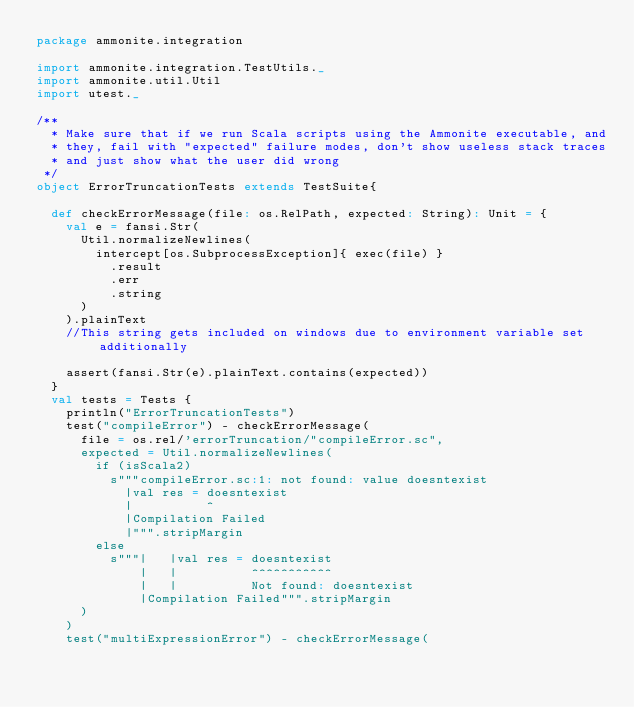Convert code to text. <code><loc_0><loc_0><loc_500><loc_500><_Scala_>package ammonite.integration

import ammonite.integration.TestUtils._
import ammonite.util.Util
import utest._

/**
  * Make sure that if we run Scala scripts using the Ammonite executable, and
  * they, fail with "expected" failure modes, don't show useless stack traces
  * and just show what the user did wrong
 */
object ErrorTruncationTests extends TestSuite{

  def checkErrorMessage(file: os.RelPath, expected: String): Unit = {
    val e = fansi.Str(
      Util.normalizeNewlines(
        intercept[os.SubprocessException]{ exec(file) }
          .result
          .err
          .string
      )
    ).plainText
    //This string gets included on windows due to environment variable set additionally

    assert(fansi.Str(e).plainText.contains(expected))
  }
  val tests = Tests {
    println("ErrorTruncationTests")
    test("compileError") - checkErrorMessage(
      file = os.rel/'errorTruncation/"compileError.sc",
      expected = Util.normalizeNewlines(
        if (isScala2)
          s"""compileError.sc:1: not found: value doesntexist
            |val res = doesntexist
            |          ^
            |Compilation Failed
            |""".stripMargin
        else
          s"""|   |val res = doesntexist
              |   |          ^^^^^^^^^^^
              |   |          Not found: doesntexist
              |Compilation Failed""".stripMargin
      )
    )
    test("multiExpressionError") - checkErrorMessage(</code> 